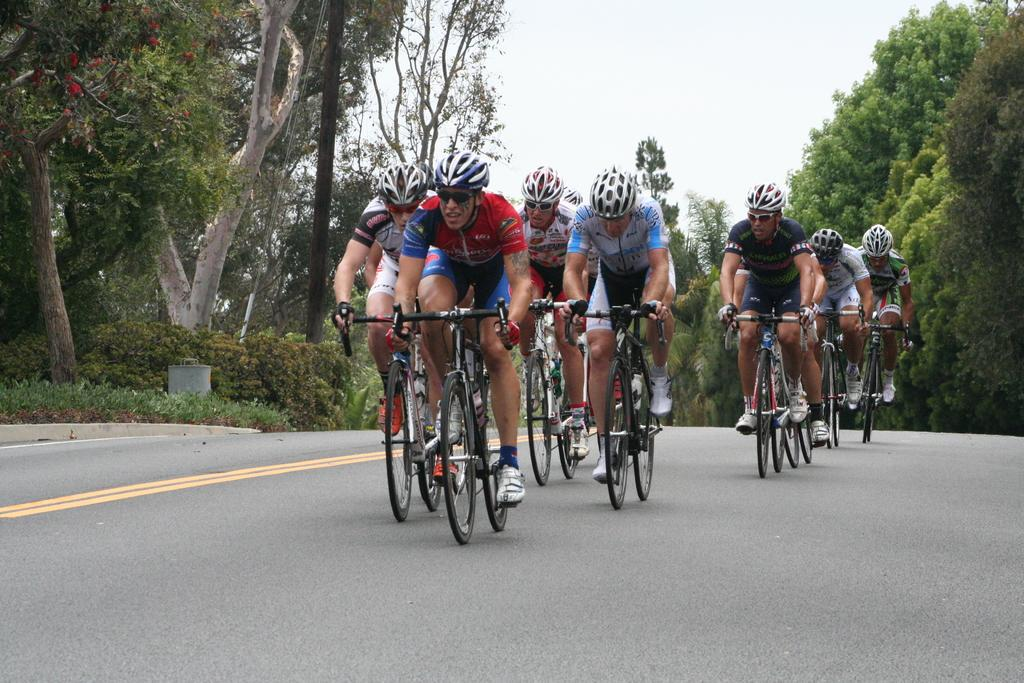What is happening in the image involving a group of men? The men in the image are riding bicycles. Where are the men riding their bicycles? The bicycles are on a road. What can be seen on either side of the road? There are trees on either side of the road. What is visible in the background of the image? The sky is visible in the background of the image. What type of clover is growing on the edge of the road in the image? There is no clover visible in the image; the trees are mentioned on either side of the road. 